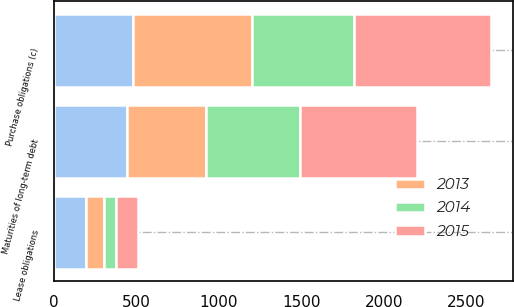<chart> <loc_0><loc_0><loc_500><loc_500><stacked_bar_chart><ecel><fcel>Maturities of long-term debt<fcel>Lease obligations<fcel>Purchase obligations (c)<nl><fcel>nan<fcel>444<fcel>198<fcel>479<nl><fcel>2015<fcel>708<fcel>136<fcel>828<nl><fcel>2013<fcel>479<fcel>106<fcel>722<nl><fcel>2014<fcel>571<fcel>70<fcel>620<nl></chart> 